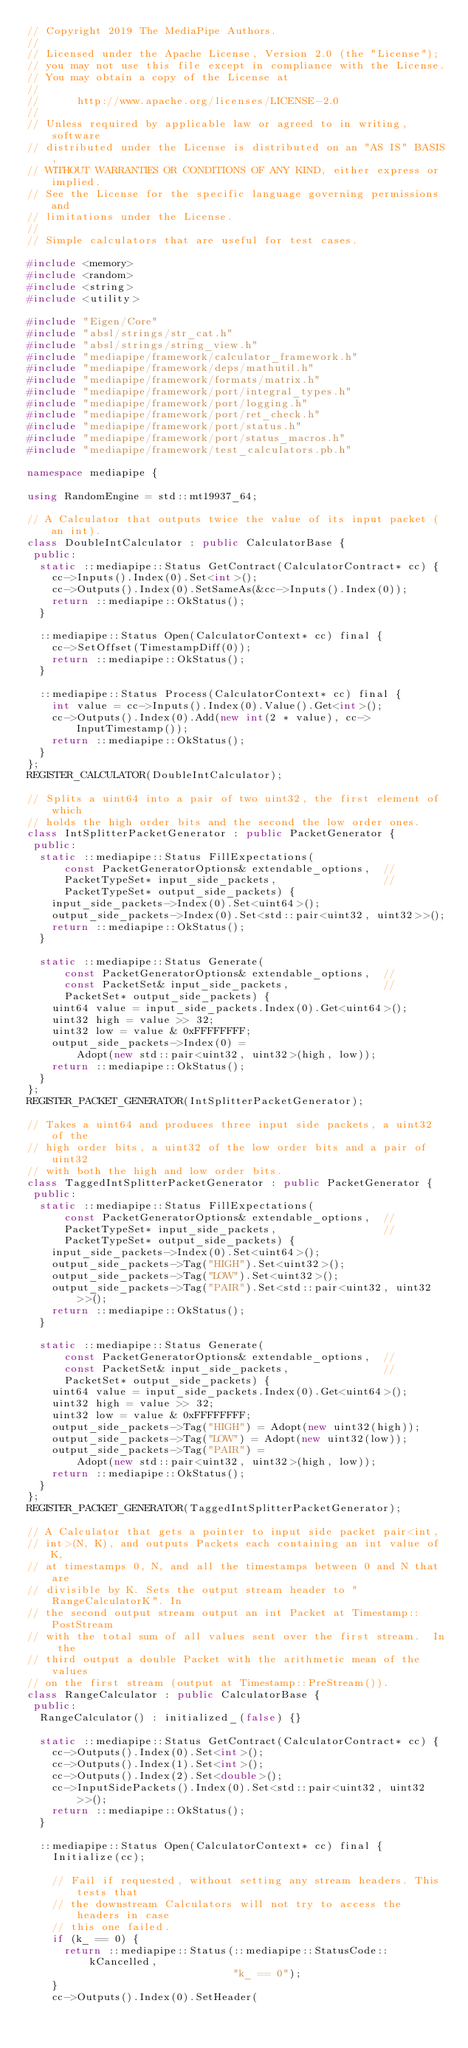<code> <loc_0><loc_0><loc_500><loc_500><_C++_>// Copyright 2019 The MediaPipe Authors.
//
// Licensed under the Apache License, Version 2.0 (the "License");
// you may not use this file except in compliance with the License.
// You may obtain a copy of the License at
//
//      http://www.apache.org/licenses/LICENSE-2.0
//
// Unless required by applicable law or agreed to in writing, software
// distributed under the License is distributed on an "AS IS" BASIS,
// WITHOUT WARRANTIES OR CONDITIONS OF ANY KIND, either express or implied.
// See the License for the specific language governing permissions and
// limitations under the License.
//
// Simple calculators that are useful for test cases.

#include <memory>
#include <random>
#include <string>
#include <utility>

#include "Eigen/Core"
#include "absl/strings/str_cat.h"
#include "absl/strings/string_view.h"
#include "mediapipe/framework/calculator_framework.h"
#include "mediapipe/framework/deps/mathutil.h"
#include "mediapipe/framework/formats/matrix.h"
#include "mediapipe/framework/port/integral_types.h"
#include "mediapipe/framework/port/logging.h"
#include "mediapipe/framework/port/ret_check.h"
#include "mediapipe/framework/port/status.h"
#include "mediapipe/framework/port/status_macros.h"
#include "mediapipe/framework/test_calculators.pb.h"

namespace mediapipe {

using RandomEngine = std::mt19937_64;

// A Calculator that outputs twice the value of its input packet (an int).
class DoubleIntCalculator : public CalculatorBase {
 public:
  static ::mediapipe::Status GetContract(CalculatorContract* cc) {
    cc->Inputs().Index(0).Set<int>();
    cc->Outputs().Index(0).SetSameAs(&cc->Inputs().Index(0));
    return ::mediapipe::OkStatus();
  }

  ::mediapipe::Status Open(CalculatorContext* cc) final {
    cc->SetOffset(TimestampDiff(0));
    return ::mediapipe::OkStatus();
  }

  ::mediapipe::Status Process(CalculatorContext* cc) final {
    int value = cc->Inputs().Index(0).Value().Get<int>();
    cc->Outputs().Index(0).Add(new int(2 * value), cc->InputTimestamp());
    return ::mediapipe::OkStatus();
  }
};
REGISTER_CALCULATOR(DoubleIntCalculator);

// Splits a uint64 into a pair of two uint32, the first element of which
// holds the high order bits and the second the low order ones.
class IntSplitterPacketGenerator : public PacketGenerator {
 public:
  static ::mediapipe::Status FillExpectations(
      const PacketGeneratorOptions& extendable_options,  //
      PacketTypeSet* input_side_packets,                 //
      PacketTypeSet* output_side_packets) {
    input_side_packets->Index(0).Set<uint64>();
    output_side_packets->Index(0).Set<std::pair<uint32, uint32>>();
    return ::mediapipe::OkStatus();
  }

  static ::mediapipe::Status Generate(
      const PacketGeneratorOptions& extendable_options,  //
      const PacketSet& input_side_packets,               //
      PacketSet* output_side_packets) {
    uint64 value = input_side_packets.Index(0).Get<uint64>();
    uint32 high = value >> 32;
    uint32 low = value & 0xFFFFFFFF;
    output_side_packets->Index(0) =
        Adopt(new std::pair<uint32, uint32>(high, low));
    return ::mediapipe::OkStatus();
  }
};
REGISTER_PACKET_GENERATOR(IntSplitterPacketGenerator);

// Takes a uint64 and produces three input side packets, a uint32 of the
// high order bits, a uint32 of the low order bits and a pair of uint32
// with both the high and low order bits.
class TaggedIntSplitterPacketGenerator : public PacketGenerator {
 public:
  static ::mediapipe::Status FillExpectations(
      const PacketGeneratorOptions& extendable_options,  //
      PacketTypeSet* input_side_packets,                 //
      PacketTypeSet* output_side_packets) {
    input_side_packets->Index(0).Set<uint64>();
    output_side_packets->Tag("HIGH").Set<uint32>();
    output_side_packets->Tag("LOW").Set<uint32>();
    output_side_packets->Tag("PAIR").Set<std::pair<uint32, uint32>>();
    return ::mediapipe::OkStatus();
  }

  static ::mediapipe::Status Generate(
      const PacketGeneratorOptions& extendable_options,  //
      const PacketSet& input_side_packets,               //
      PacketSet* output_side_packets) {
    uint64 value = input_side_packets.Index(0).Get<uint64>();
    uint32 high = value >> 32;
    uint32 low = value & 0xFFFFFFFF;
    output_side_packets->Tag("HIGH") = Adopt(new uint32(high));
    output_side_packets->Tag("LOW") = Adopt(new uint32(low));
    output_side_packets->Tag("PAIR") =
        Adopt(new std::pair<uint32, uint32>(high, low));
    return ::mediapipe::OkStatus();
  }
};
REGISTER_PACKET_GENERATOR(TaggedIntSplitterPacketGenerator);

// A Calculator that gets a pointer to input side packet pair<int,
// int>(N, K), and outputs Packets each containing an int value of K,
// at timestamps 0, N, and all the timestamps between 0 and N that are
// divisible by K. Sets the output stream header to "RangeCalculatorK". In
// the second output stream output an int Packet at Timestamp::PostStream
// with the total sum of all values sent over the first stream.  In the
// third output a double Packet with the arithmetic mean of the values
// on the first stream (output at Timestamp::PreStream()).
class RangeCalculator : public CalculatorBase {
 public:
  RangeCalculator() : initialized_(false) {}

  static ::mediapipe::Status GetContract(CalculatorContract* cc) {
    cc->Outputs().Index(0).Set<int>();
    cc->Outputs().Index(1).Set<int>();
    cc->Outputs().Index(2).Set<double>();
    cc->InputSidePackets().Index(0).Set<std::pair<uint32, uint32>>();
    return ::mediapipe::OkStatus();
  }

  ::mediapipe::Status Open(CalculatorContext* cc) final {
    Initialize(cc);

    // Fail if requested, without setting any stream headers. This tests that
    // the downstream Calculators will not try to access the headers in case
    // this one failed.
    if (k_ == 0) {
      return ::mediapipe::Status(::mediapipe::StatusCode::kCancelled,
                                 "k_ == 0");
    }
    cc->Outputs().Index(0).SetHeader(</code> 